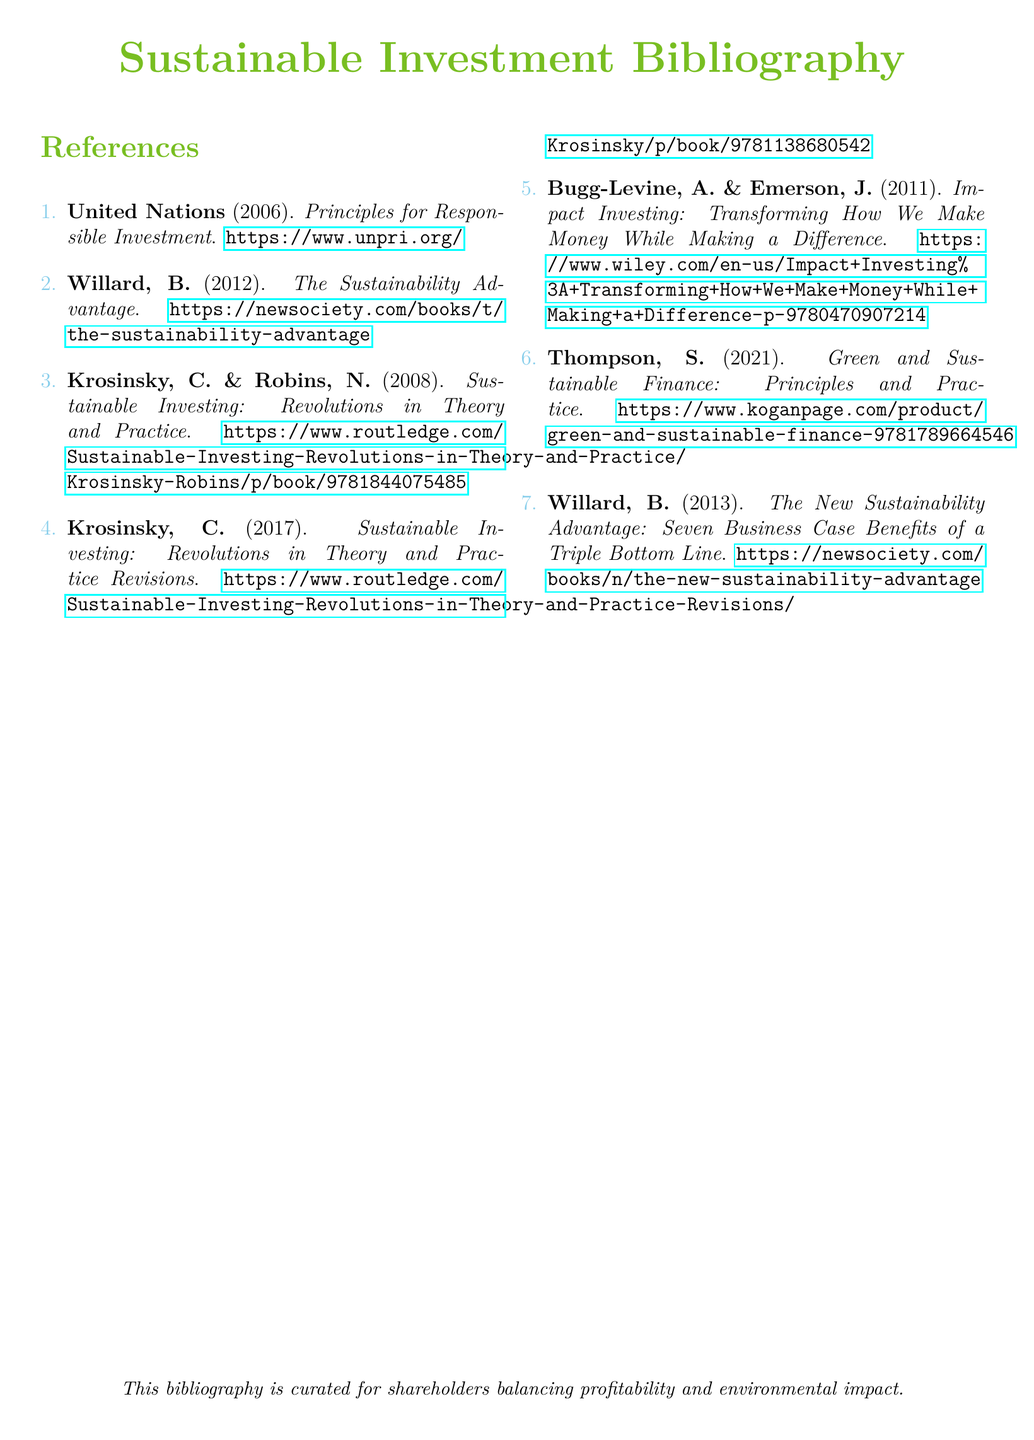What year was the Principles for Responsible Investment published? The publication year for the Principles for Responsible Investment is stated in the document.
Answer: 2006 Who are the authors of "Impact Investing: Transforming How We Make Money While Making a Difference"? The document lists the authors for this book, which helps identify the contributors to the work.
Answer: Bugg-Levine, A. & Emerson, J How many references are listed in the bibliography? The total number of entries in the bibliography indicates the amount of material reviewed or suggested.
Answer: 7 What is the title of the book written by S. Thompson? The title related to S. Thompson contains important details about the focus of their work on sustainable finance.
Answer: Green and Sustainable Finance: Principles and Practice Which author wrote two different entries on sustainability? The document reveals that one author has contributed multiple works, highlighting their significance in the field.
Answer: Willard, B What is the primary subject of the bibliography? The subject area of the bibliography indicates the overarching theme all referenced works contribute to.
Answer: Sustainable Investment 